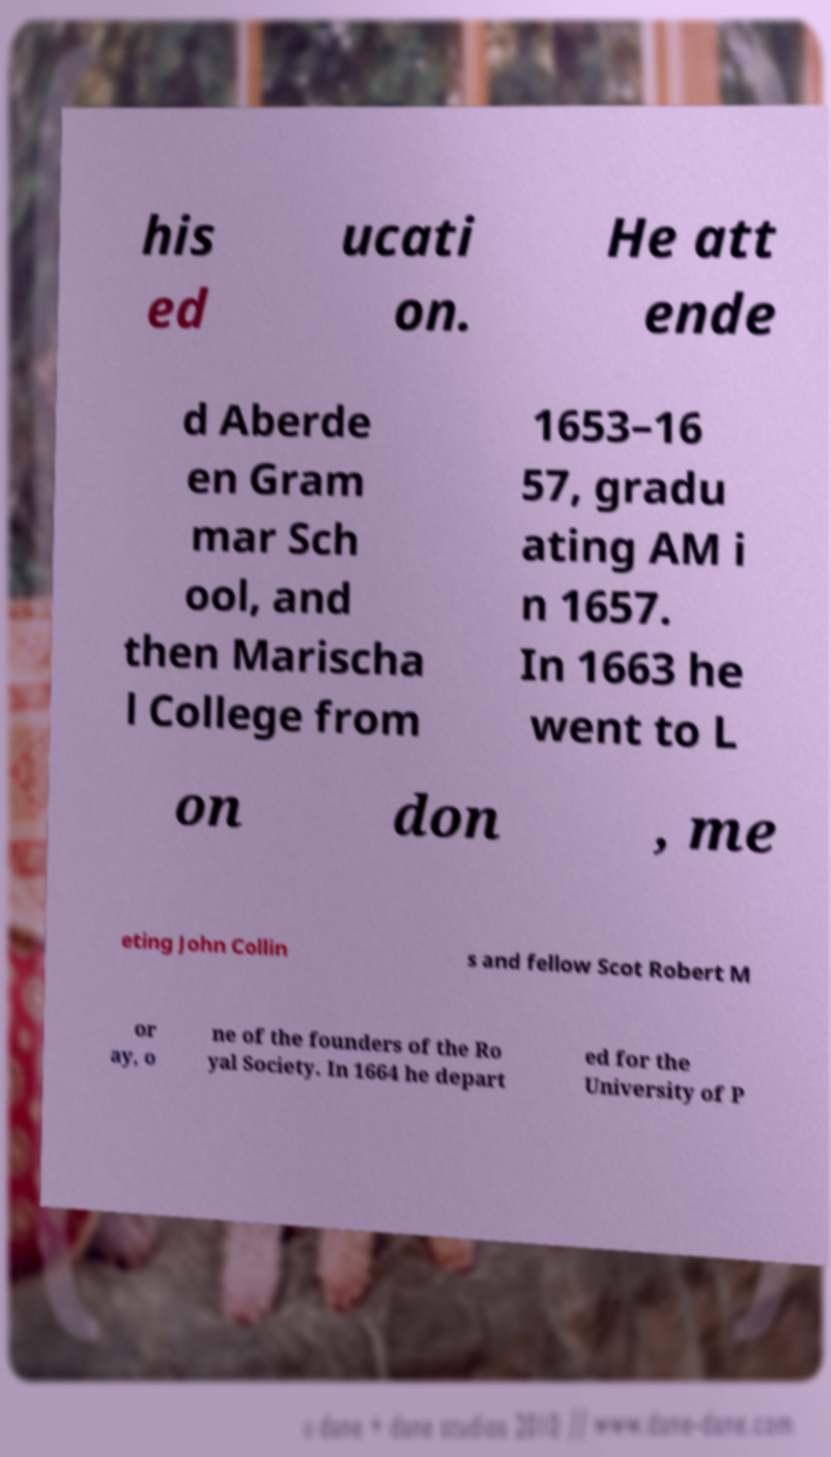There's text embedded in this image that I need extracted. Can you transcribe it verbatim? his ed ucati on. He att ende d Aberde en Gram mar Sch ool, and then Marischa l College from 1653–16 57, gradu ating AM i n 1657. In 1663 he went to L on don , me eting John Collin s and fellow Scot Robert M or ay, o ne of the founders of the Ro yal Society. In 1664 he depart ed for the University of P 